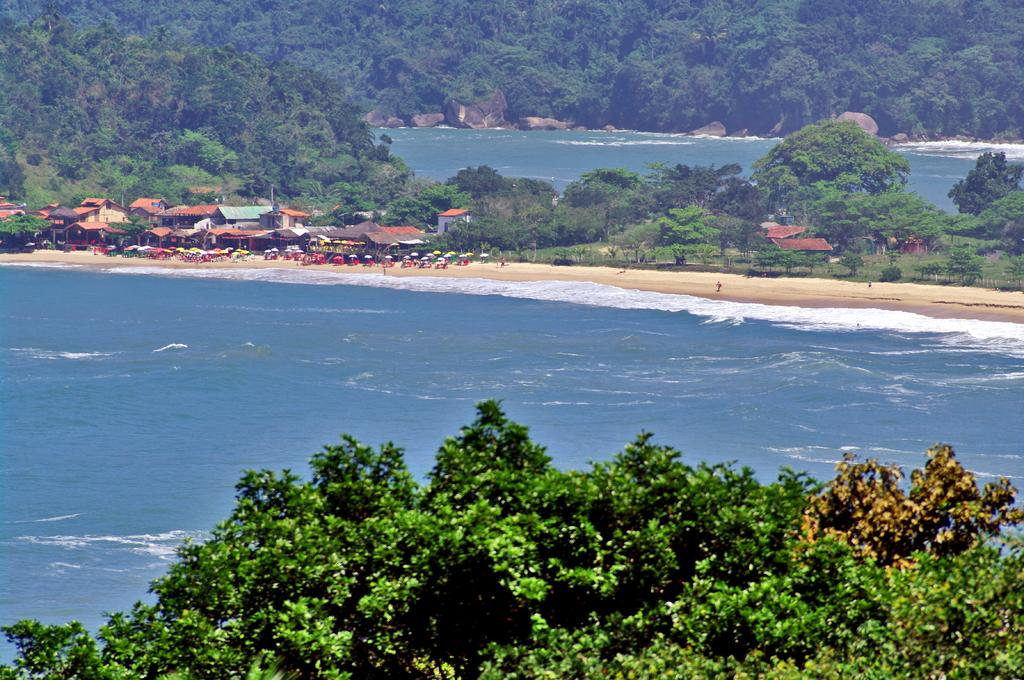What type of vegetation is at the bottom of the image? There are trees at the bottom of the image. What natural feature is visible in the image? There are waves and water visible in the image, which is part of an ocean. What structures can be seen in the middle of the image? There are houses in the middle of the image. Who or what is present in the image? There are people in the image. What type of temporary shelter is visible in the image? There are tents in the image. What objects are present for protection from the sun or rain? There are umbrellas in the image. What other type of vegetation is present in the middle of the image? There are additional trees in the middle of the image. Can you describe the water in the middle of the image? There is water visible in the middle of the image. Can you hear the hen cry in the image? There is no hen or any indication of sound in the image. What type of birds can be seen flying over the ocean in the image? There are no birds visible in the image. 